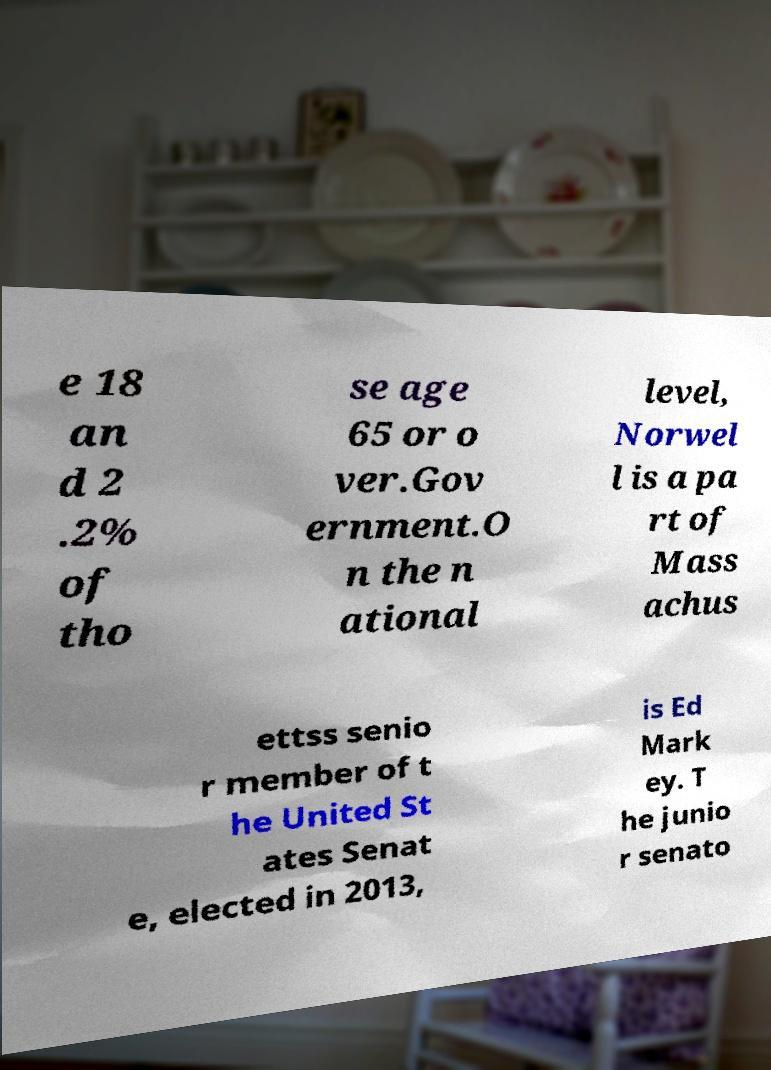I need the written content from this picture converted into text. Can you do that? e 18 an d 2 .2% of tho se age 65 or o ver.Gov ernment.O n the n ational level, Norwel l is a pa rt of Mass achus ettss senio r member of t he United St ates Senat e, elected in 2013, is Ed Mark ey. T he junio r senato 